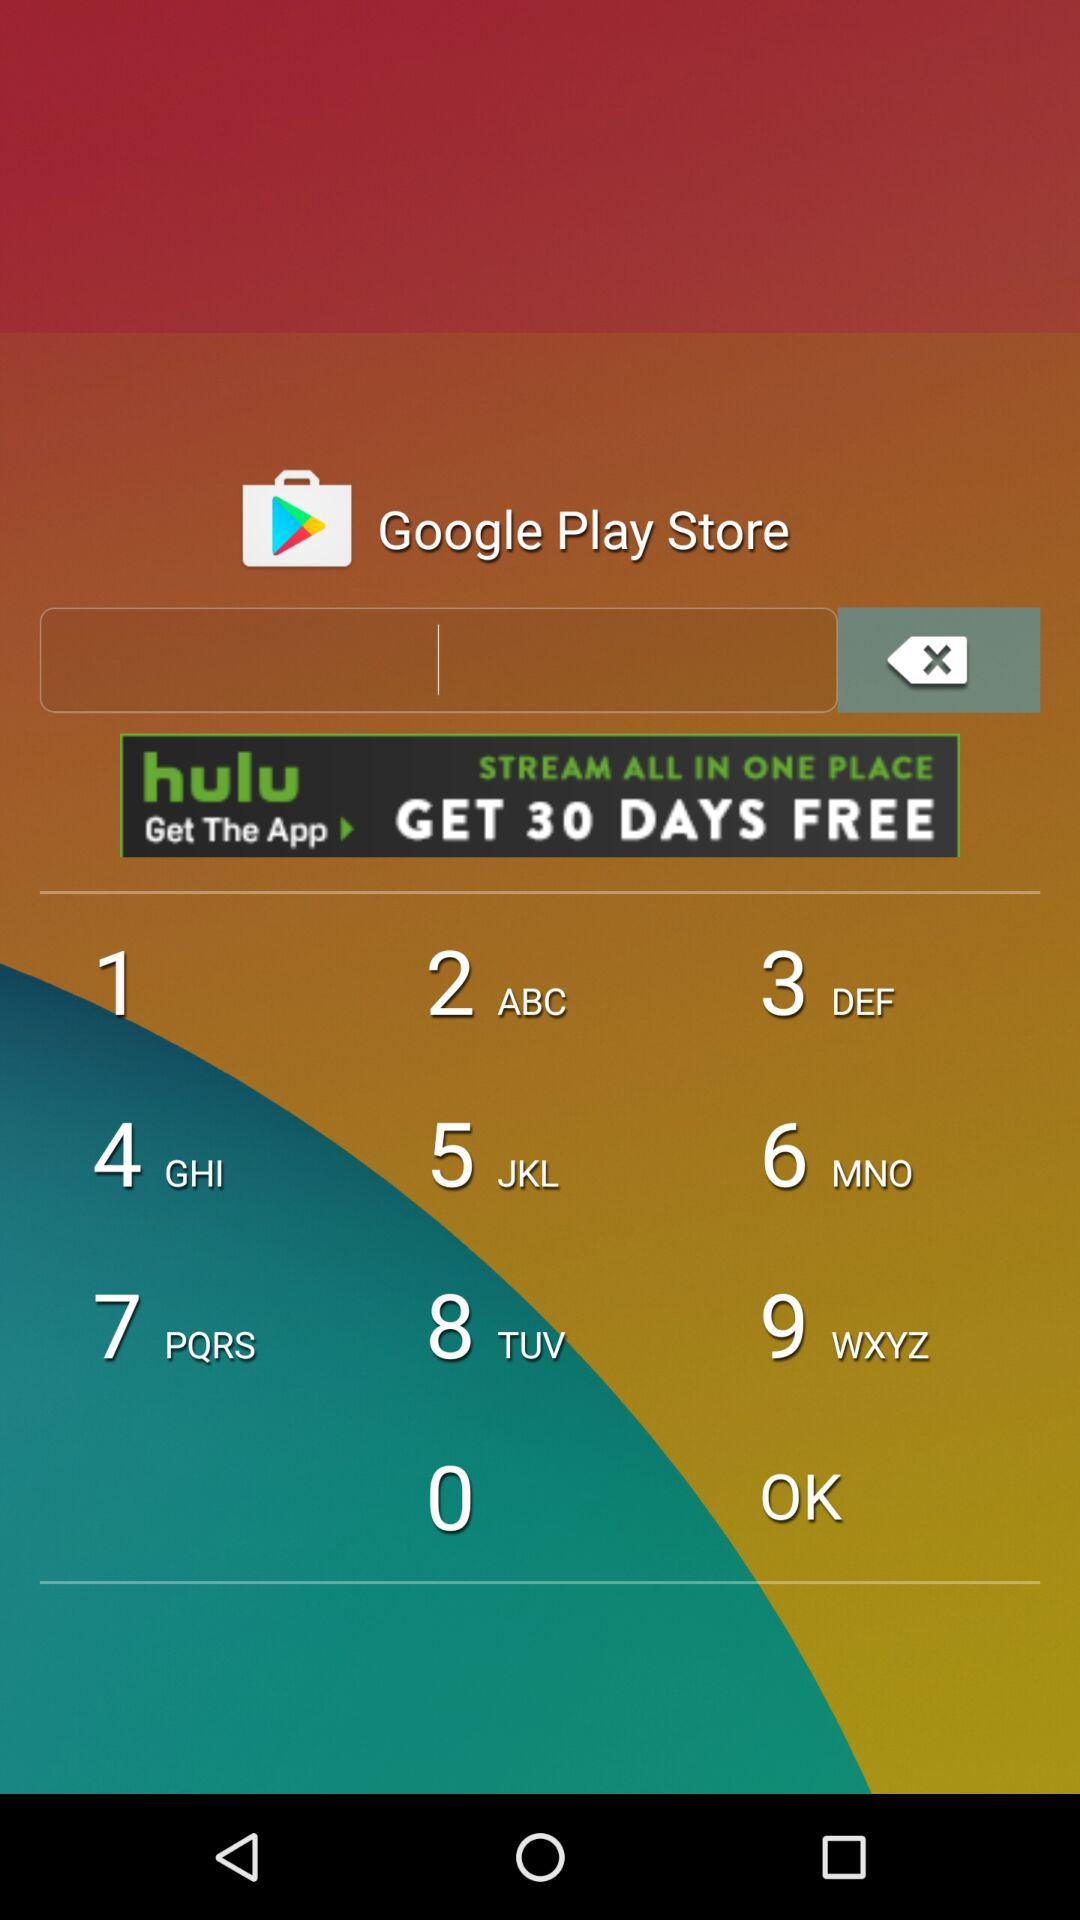What is the year? The year is 2015. 